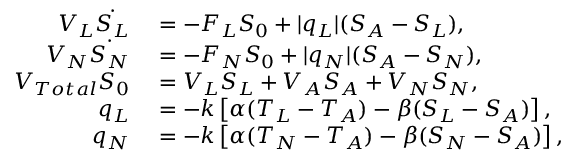<formula> <loc_0><loc_0><loc_500><loc_500>\begin{array} { r l } { V _ { L } \dot { S _ { L } } } & = - F _ { L } S _ { 0 } + | q _ { L } | ( S _ { A } - S _ { L } ) , } \\ { V _ { N } \dot { S _ { N } } } & = - F _ { N } S _ { 0 } + | q _ { N } | ( S _ { A } - S _ { N } ) , } \\ { V _ { T o t a l } S _ { 0 } } & = V _ { L } S _ { L } + V _ { A } S _ { A } + V _ { N } S _ { N } , } \\ { q _ { L } } & = - k \left [ \alpha ( T _ { L } - T _ { A } ) - \beta ( S _ { L } - S _ { A } ) \right ] , } \\ { q _ { N } } & = - k \left [ \alpha ( T _ { N } - T _ { A } ) - \beta ( S _ { N } - S _ { A } ) \right ] , } \end{array}</formula> 